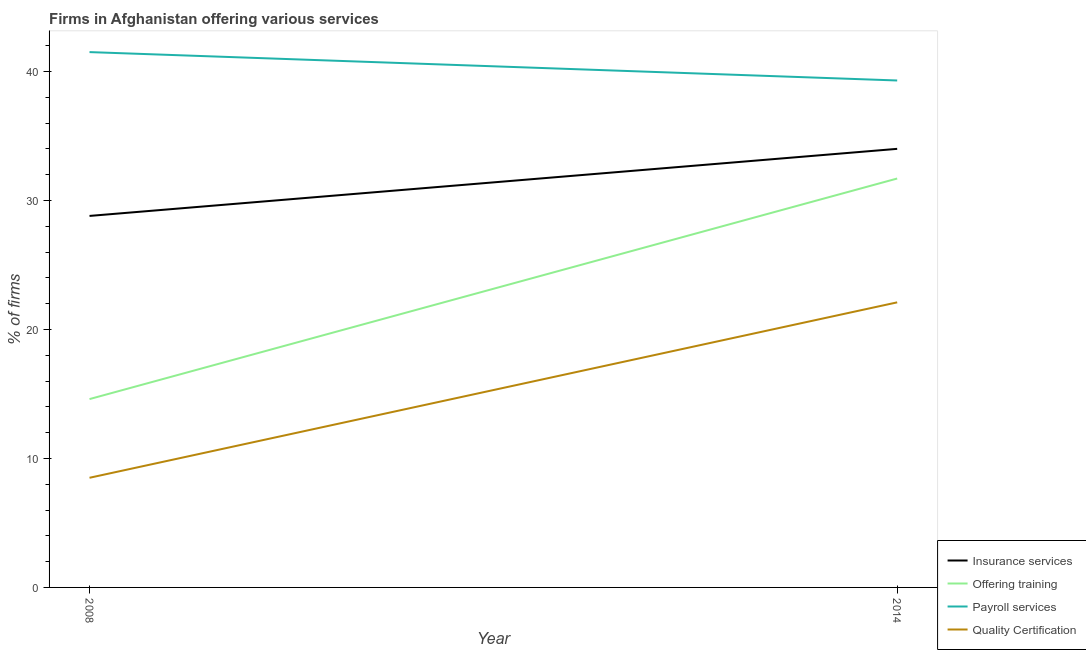What is the percentage of firms offering payroll services in 2014?
Provide a short and direct response. 39.3. Across all years, what is the maximum percentage of firms offering payroll services?
Make the answer very short. 41.5. Across all years, what is the minimum percentage of firms offering quality certification?
Your answer should be very brief. 8.5. In which year was the percentage of firms offering quality certification maximum?
Offer a very short reply. 2014. In which year was the percentage of firms offering insurance services minimum?
Your answer should be very brief. 2008. What is the total percentage of firms offering insurance services in the graph?
Offer a terse response. 62.8. What is the difference between the percentage of firms offering payroll services in 2008 and that in 2014?
Your response must be concise. 2.2. What is the difference between the percentage of firms offering payroll services in 2014 and the percentage of firms offering insurance services in 2008?
Your response must be concise. 10.5. What is the average percentage of firms offering insurance services per year?
Provide a succinct answer. 31.4. In the year 2014, what is the difference between the percentage of firms offering payroll services and percentage of firms offering insurance services?
Offer a very short reply. 5.3. In how many years, is the percentage of firms offering training greater than 10 %?
Make the answer very short. 2. What is the ratio of the percentage of firms offering insurance services in 2008 to that in 2014?
Your answer should be compact. 0.85. Is the percentage of firms offering insurance services in 2008 less than that in 2014?
Make the answer very short. Yes. Is it the case that in every year, the sum of the percentage of firms offering insurance services and percentage of firms offering training is greater than the percentage of firms offering payroll services?
Offer a very short reply. Yes. Does the percentage of firms offering payroll services monotonically increase over the years?
Your answer should be compact. No. How many lines are there?
Make the answer very short. 4. Does the graph contain grids?
Your answer should be compact. No. Where does the legend appear in the graph?
Offer a terse response. Bottom right. How many legend labels are there?
Keep it short and to the point. 4. How are the legend labels stacked?
Your answer should be very brief. Vertical. What is the title of the graph?
Keep it short and to the point. Firms in Afghanistan offering various services . What is the label or title of the Y-axis?
Your answer should be compact. % of firms. What is the % of firms of Insurance services in 2008?
Keep it short and to the point. 28.8. What is the % of firms in Offering training in 2008?
Provide a succinct answer. 14.6. What is the % of firms of Payroll services in 2008?
Make the answer very short. 41.5. What is the % of firms of Quality Certification in 2008?
Offer a terse response. 8.5. What is the % of firms of Insurance services in 2014?
Keep it short and to the point. 34. What is the % of firms in Offering training in 2014?
Ensure brevity in your answer.  31.7. What is the % of firms in Payroll services in 2014?
Provide a succinct answer. 39.3. What is the % of firms of Quality Certification in 2014?
Provide a succinct answer. 22.1. Across all years, what is the maximum % of firms in Offering training?
Your answer should be compact. 31.7. Across all years, what is the maximum % of firms of Payroll services?
Give a very brief answer. 41.5. Across all years, what is the maximum % of firms of Quality Certification?
Provide a succinct answer. 22.1. Across all years, what is the minimum % of firms in Insurance services?
Your answer should be compact. 28.8. Across all years, what is the minimum % of firms in Offering training?
Make the answer very short. 14.6. Across all years, what is the minimum % of firms in Payroll services?
Give a very brief answer. 39.3. What is the total % of firms in Insurance services in the graph?
Your answer should be very brief. 62.8. What is the total % of firms of Offering training in the graph?
Provide a succinct answer. 46.3. What is the total % of firms of Payroll services in the graph?
Your response must be concise. 80.8. What is the total % of firms in Quality Certification in the graph?
Offer a terse response. 30.6. What is the difference between the % of firms of Insurance services in 2008 and that in 2014?
Make the answer very short. -5.2. What is the difference between the % of firms in Offering training in 2008 and that in 2014?
Make the answer very short. -17.1. What is the difference between the % of firms of Payroll services in 2008 and that in 2014?
Your answer should be very brief. 2.2. What is the difference between the % of firms of Insurance services in 2008 and the % of firms of Offering training in 2014?
Your answer should be very brief. -2.9. What is the difference between the % of firms in Insurance services in 2008 and the % of firms in Payroll services in 2014?
Provide a succinct answer. -10.5. What is the difference between the % of firms in Insurance services in 2008 and the % of firms in Quality Certification in 2014?
Provide a succinct answer. 6.7. What is the difference between the % of firms in Offering training in 2008 and the % of firms in Payroll services in 2014?
Keep it short and to the point. -24.7. What is the difference between the % of firms of Offering training in 2008 and the % of firms of Quality Certification in 2014?
Your answer should be very brief. -7.5. What is the difference between the % of firms in Payroll services in 2008 and the % of firms in Quality Certification in 2014?
Offer a very short reply. 19.4. What is the average % of firms of Insurance services per year?
Your answer should be compact. 31.4. What is the average % of firms in Offering training per year?
Provide a short and direct response. 23.15. What is the average % of firms of Payroll services per year?
Your answer should be very brief. 40.4. What is the average % of firms of Quality Certification per year?
Provide a short and direct response. 15.3. In the year 2008, what is the difference between the % of firms of Insurance services and % of firms of Payroll services?
Your answer should be very brief. -12.7. In the year 2008, what is the difference between the % of firms in Insurance services and % of firms in Quality Certification?
Offer a very short reply. 20.3. In the year 2008, what is the difference between the % of firms of Offering training and % of firms of Payroll services?
Provide a short and direct response. -26.9. In the year 2014, what is the difference between the % of firms in Insurance services and % of firms in Offering training?
Keep it short and to the point. 2.3. In the year 2014, what is the difference between the % of firms in Insurance services and % of firms in Payroll services?
Keep it short and to the point. -5.3. In the year 2014, what is the difference between the % of firms in Offering training and % of firms in Quality Certification?
Provide a short and direct response. 9.6. What is the ratio of the % of firms of Insurance services in 2008 to that in 2014?
Your response must be concise. 0.85. What is the ratio of the % of firms of Offering training in 2008 to that in 2014?
Make the answer very short. 0.46. What is the ratio of the % of firms of Payroll services in 2008 to that in 2014?
Give a very brief answer. 1.06. What is the ratio of the % of firms in Quality Certification in 2008 to that in 2014?
Give a very brief answer. 0.38. What is the difference between the highest and the second highest % of firms of Insurance services?
Your answer should be compact. 5.2. What is the difference between the highest and the second highest % of firms of Payroll services?
Offer a very short reply. 2.2. What is the difference between the highest and the lowest % of firms in Insurance services?
Ensure brevity in your answer.  5.2. What is the difference between the highest and the lowest % of firms in Payroll services?
Give a very brief answer. 2.2. 